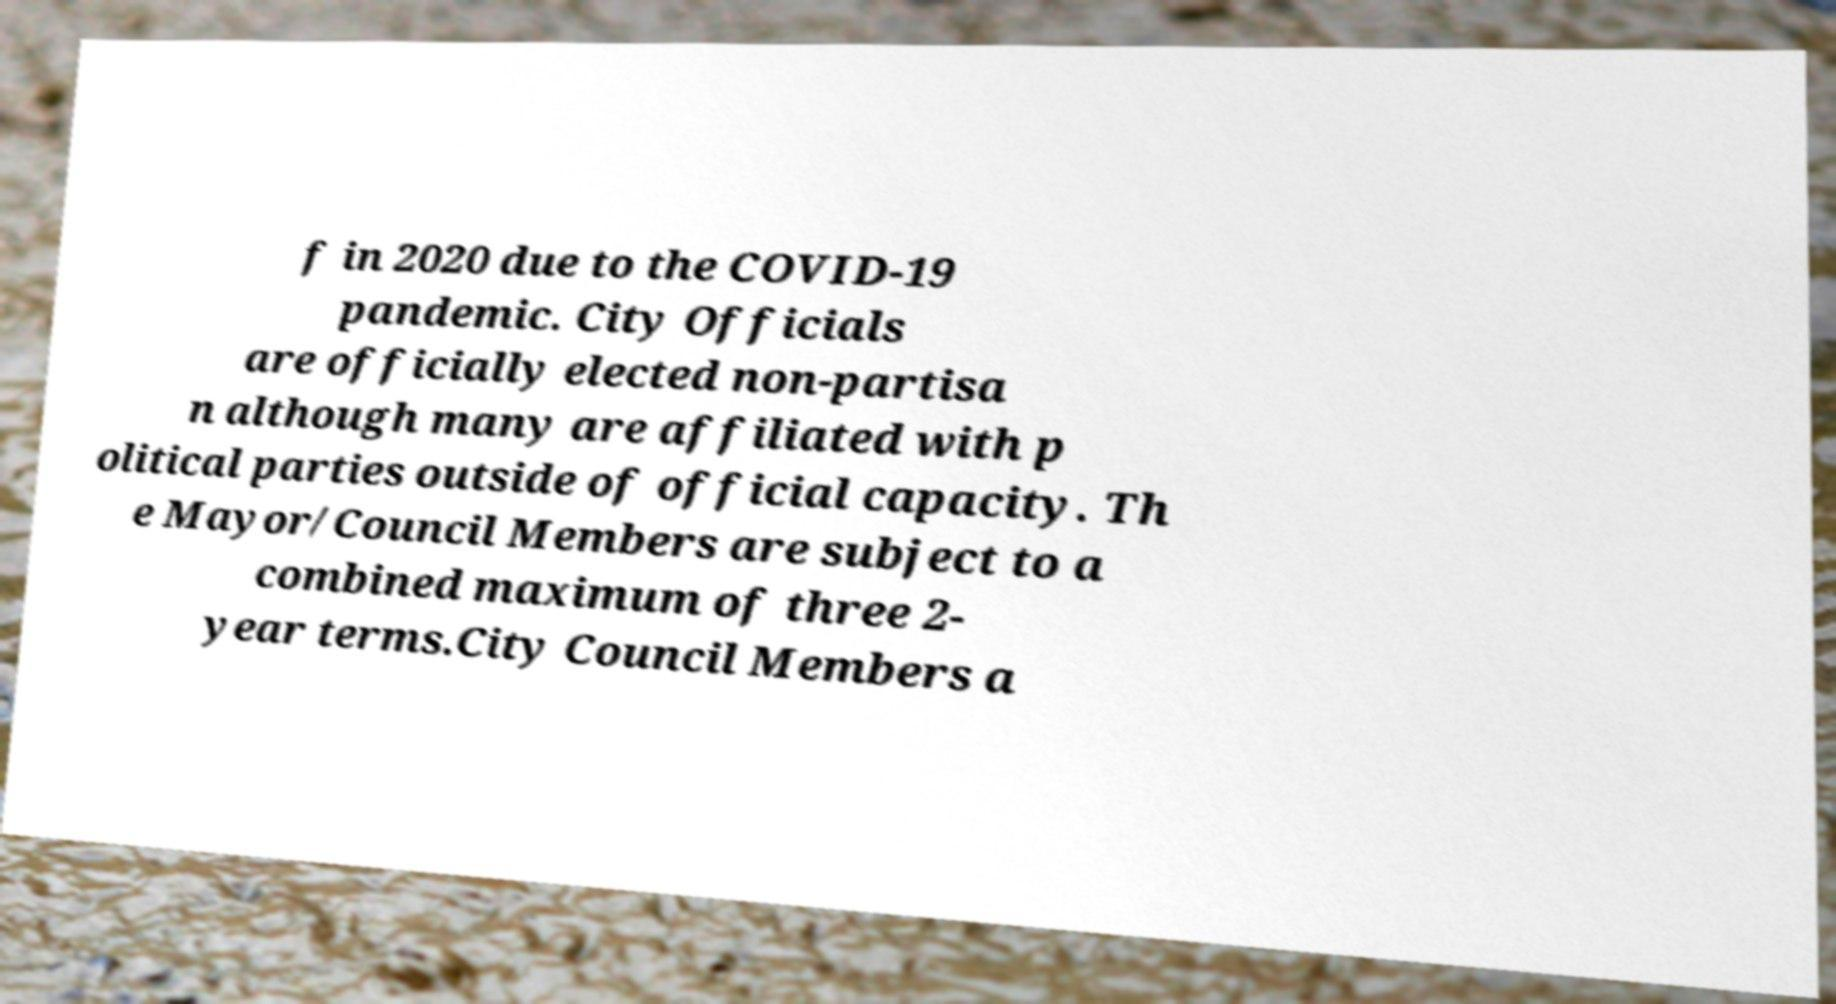What messages or text are displayed in this image? I need them in a readable, typed format. f in 2020 due to the COVID-19 pandemic. City Officials are officially elected non-partisa n although many are affiliated with p olitical parties outside of official capacity. Th e Mayor/Council Members are subject to a combined maximum of three 2- year terms.City Council Members a 